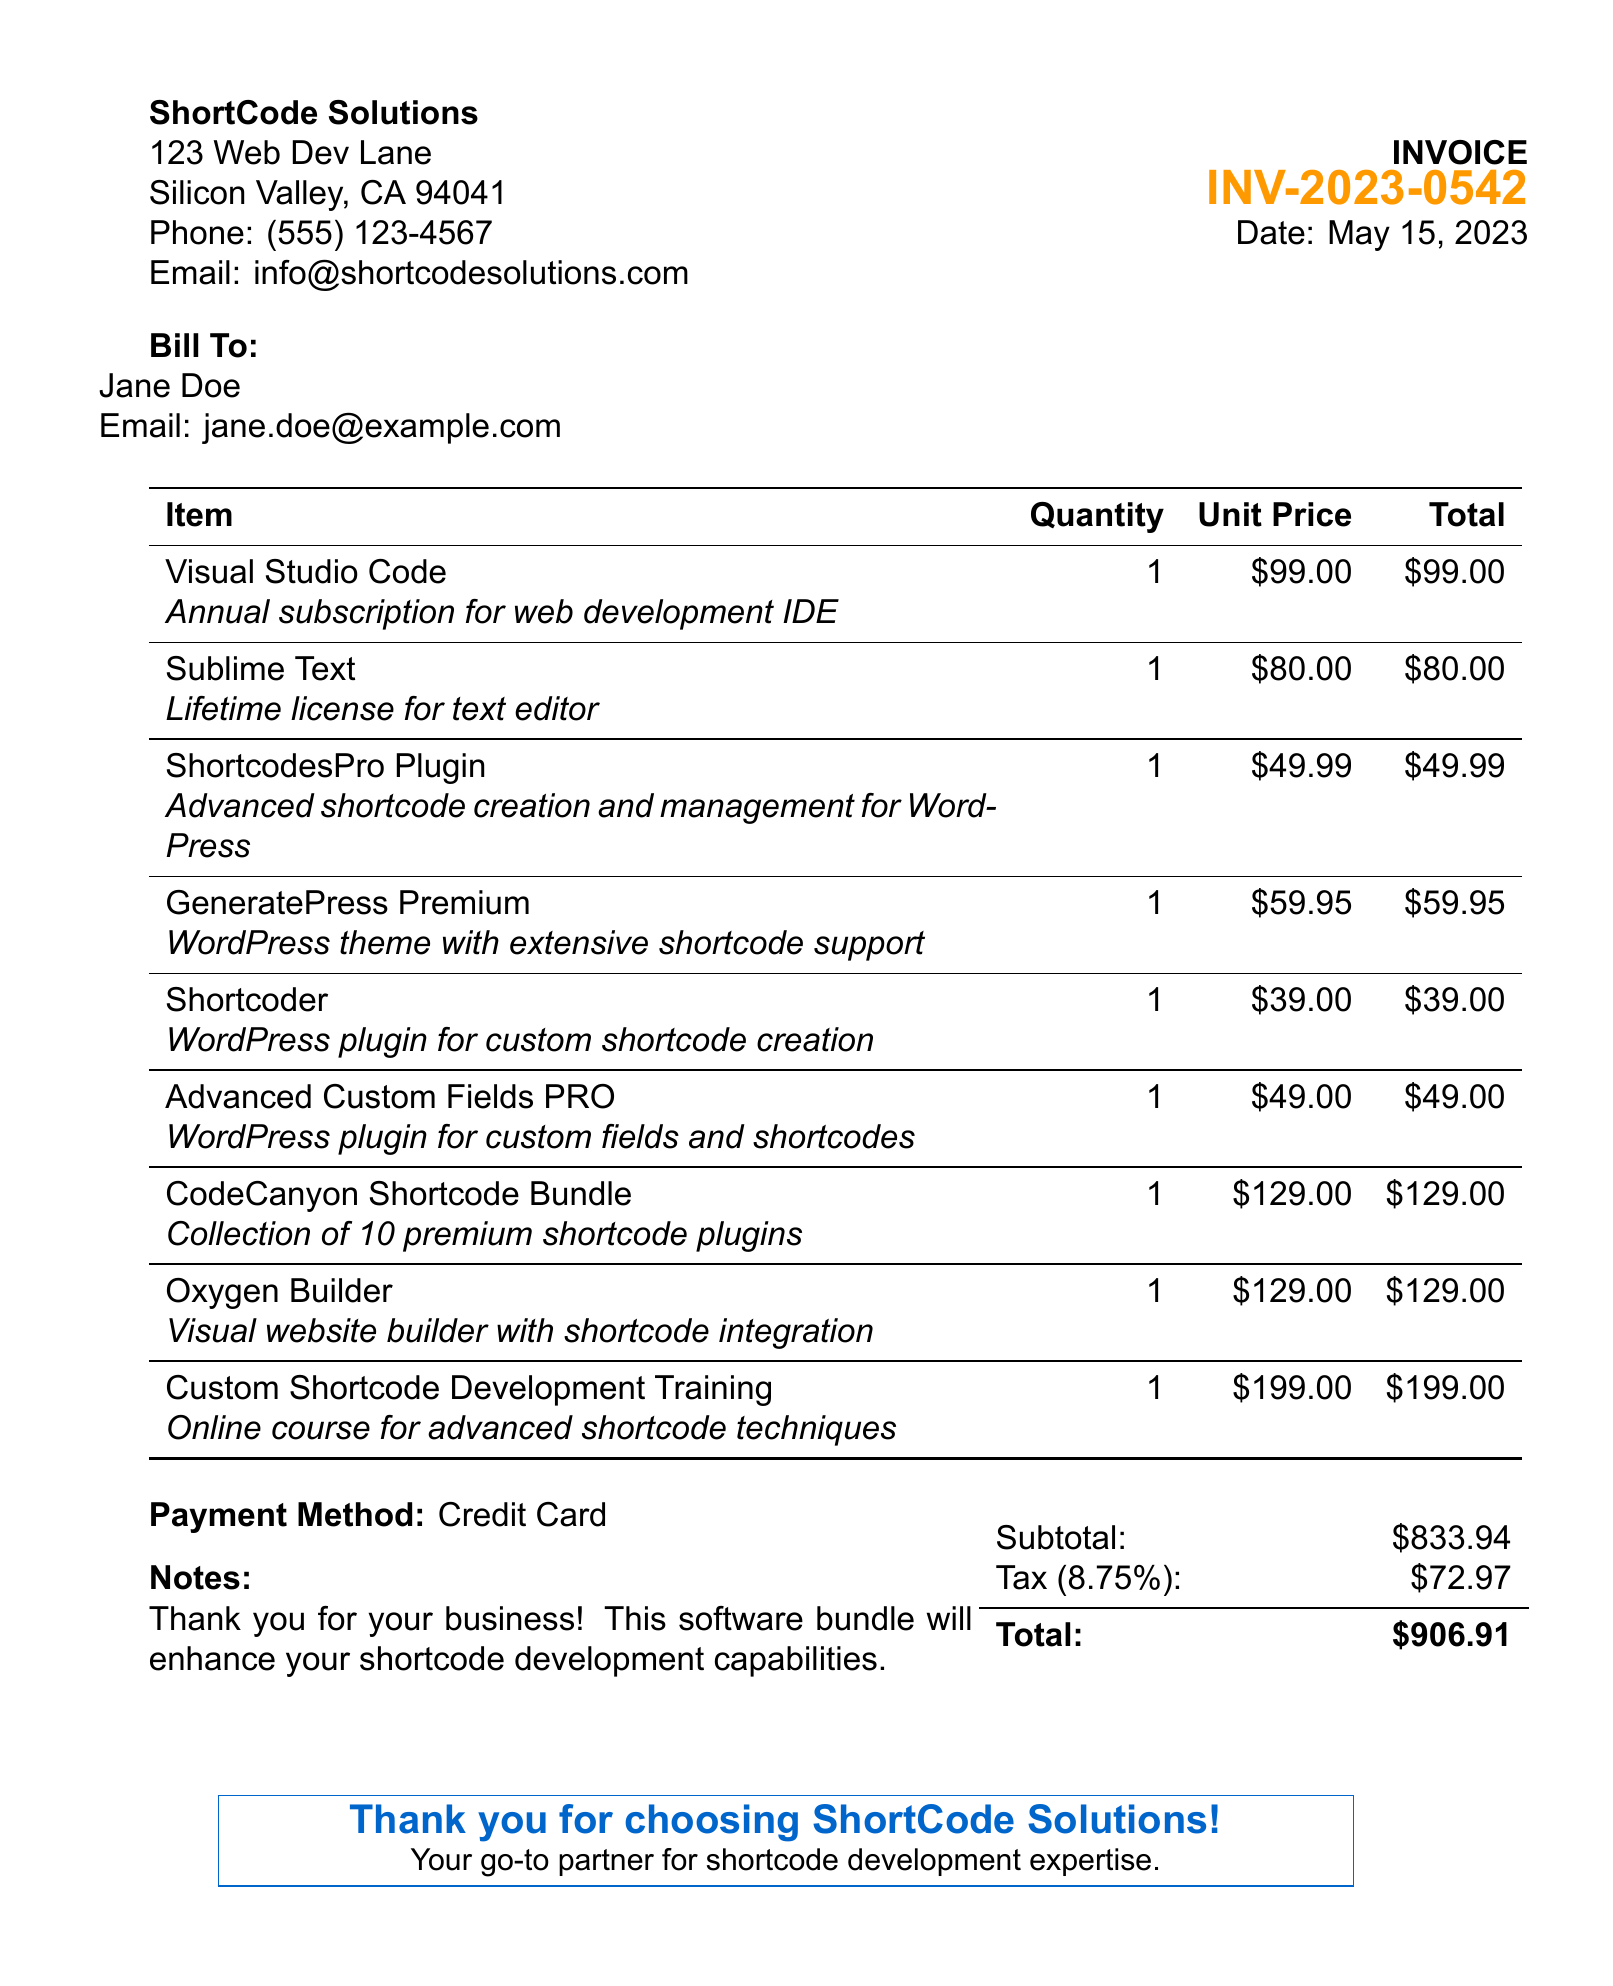What is the invoice number? The invoice number is listed prominently in the document, identifying the specific transaction.
Answer: INV-2023-0542 What is the total amount due? The total amount due is calculated by adding the subtotal and tax, which is presented at the bottom of the receipt.
Answer: $906.91 Who is the customer? The customer's name is provided in the bill-to section, indicating to whom the invoice is addressed.
Answer: Jane Doe What is the subtotal of the items? The subtotal of the items before tax is shown in the financial summary of the receipt.
Answer: $833.94 Which plugin is specifically for custom shortcode creation? The description outlines that one of the plugins is designed exclusively for creating custom shortcodes in WordPress.
Answer: Shortcoder How many items are listed in the receipt? The receipt contains a detailed list of all the items purchased, providing an overview of the order.
Answer: 9 What is the payment method used? The payment method is stated towards the end of the receipt, indicating how the transaction was completed.
Answer: Credit Card What is the tax rate applied? The tax rate is expressed in percentage form and is important for calculating the total amount due.
Answer: 8.75% What type of course is included in the items? The course offered in the items is focused on specialized techniques relevant to shortcode development.
Answer: Online course for advanced shortcode techniques 